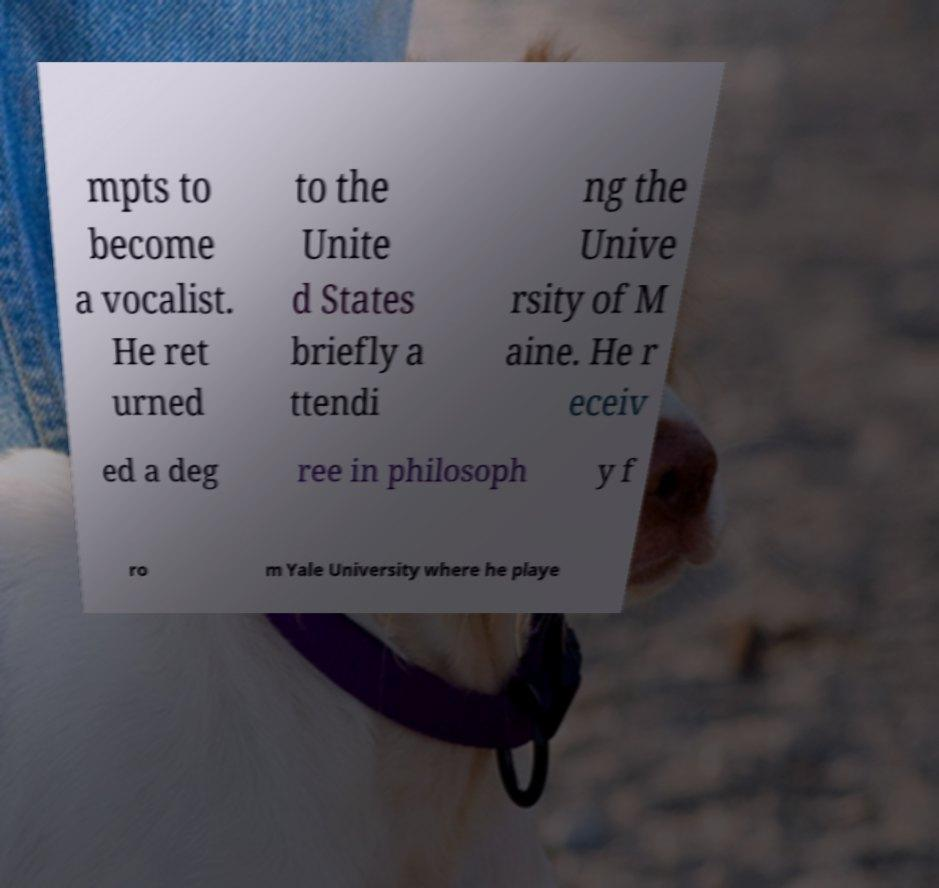Could you assist in decoding the text presented in this image and type it out clearly? mpts to become a vocalist. He ret urned to the Unite d States briefly a ttendi ng the Unive rsity of M aine. He r eceiv ed a deg ree in philosoph y f ro m Yale University where he playe 